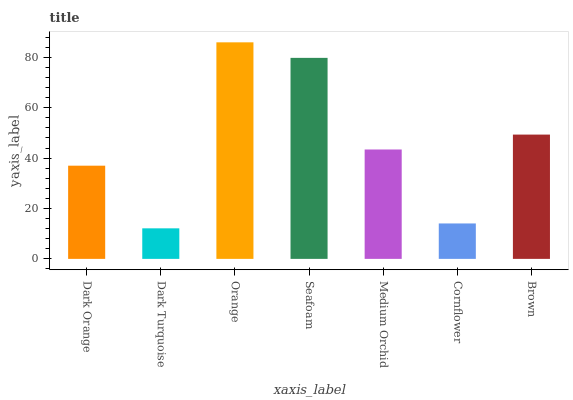Is Dark Turquoise the minimum?
Answer yes or no. Yes. Is Orange the maximum?
Answer yes or no. Yes. Is Orange the minimum?
Answer yes or no. No. Is Dark Turquoise the maximum?
Answer yes or no. No. Is Orange greater than Dark Turquoise?
Answer yes or no. Yes. Is Dark Turquoise less than Orange?
Answer yes or no. Yes. Is Dark Turquoise greater than Orange?
Answer yes or no. No. Is Orange less than Dark Turquoise?
Answer yes or no. No. Is Medium Orchid the high median?
Answer yes or no. Yes. Is Medium Orchid the low median?
Answer yes or no. Yes. Is Seafoam the high median?
Answer yes or no. No. Is Seafoam the low median?
Answer yes or no. No. 